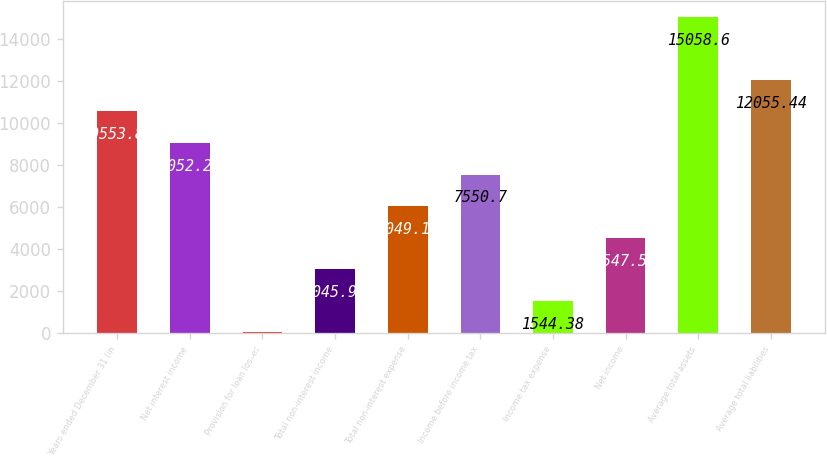Convert chart to OTSL. <chart><loc_0><loc_0><loc_500><loc_500><bar_chart><fcel>Years ended December 31 (in<fcel>Net interest income<fcel>Provision for loan losses<fcel>Total non-interest income<fcel>Total non-interest expense<fcel>Income before income tax<fcel>Income tax expense<fcel>Net income<fcel>Average total assets<fcel>Average total liabilities<nl><fcel>10553.9<fcel>9052.28<fcel>42.8<fcel>3045.96<fcel>6049.12<fcel>7550.7<fcel>1544.38<fcel>4547.54<fcel>15058.6<fcel>12055.4<nl></chart> 